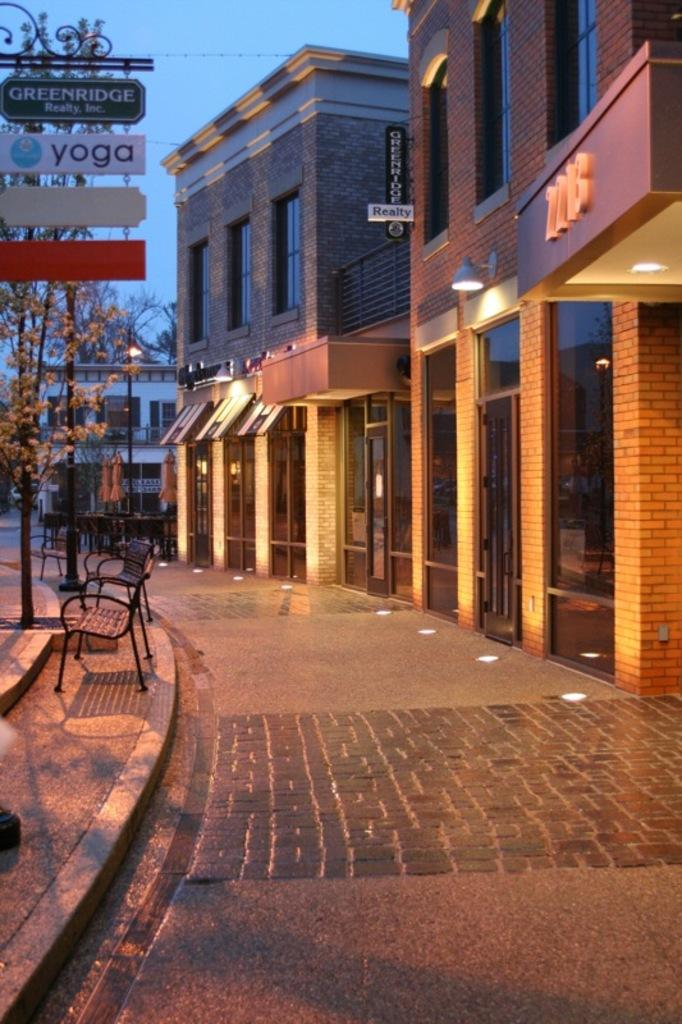What type of structures can be seen in the image? There are buildings in the image. What can be seen illuminating the area in the image? There are lights in the image. What type of information might be displayed in the image? There are sign boards in the image that could display information. What type of natural elements are present in the image? Trees are present in the image. What type of seating can be seen in the image? There are benches in the image. What type of stew is being served in the image? There is no stew present in the image. What type of wax can be seen dripping from the lights in the image? There is no wax dripping from the lights in the image. 